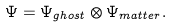Convert formula to latex. <formula><loc_0><loc_0><loc_500><loc_500>\Psi = \Psi _ { g h o s t } \otimes \Psi _ { m a t t e r } .</formula> 